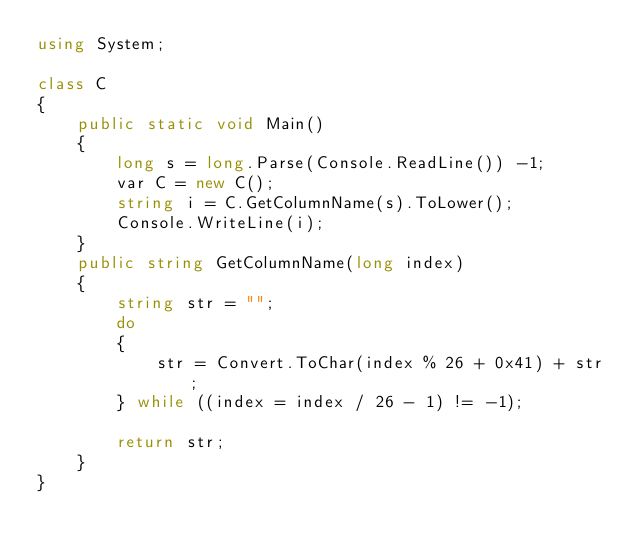<code> <loc_0><loc_0><loc_500><loc_500><_C#_>using System;

class C
{
    public static void Main()
    {
        long s = long.Parse(Console.ReadLine()) -1;
        var C = new C();
        string i = C.GetColumnName(s).ToLower();
        Console.WriteLine(i);
    }
    public string GetColumnName(long index)
    {
        string str = "";
        do
        {
            str = Convert.ToChar(index % 26 + 0x41) + str;
        } while ((index = index / 26 - 1) != -1);

        return str;
    }
}

</code> 